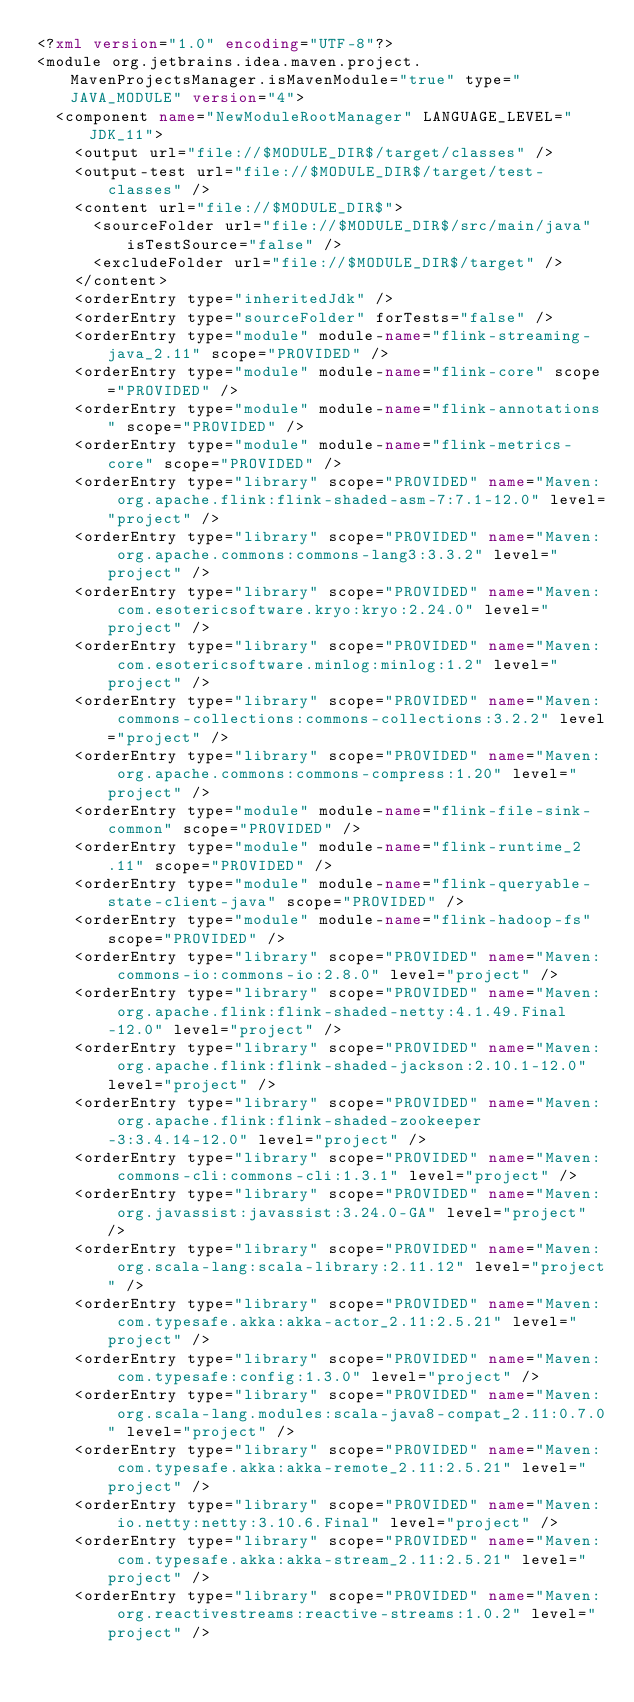<code> <loc_0><loc_0><loc_500><loc_500><_XML_><?xml version="1.0" encoding="UTF-8"?>
<module org.jetbrains.idea.maven.project.MavenProjectsManager.isMavenModule="true" type="JAVA_MODULE" version="4">
  <component name="NewModuleRootManager" LANGUAGE_LEVEL="JDK_11">
    <output url="file://$MODULE_DIR$/target/classes" />
    <output-test url="file://$MODULE_DIR$/target/test-classes" />
    <content url="file://$MODULE_DIR$">
      <sourceFolder url="file://$MODULE_DIR$/src/main/java" isTestSource="false" />
      <excludeFolder url="file://$MODULE_DIR$/target" />
    </content>
    <orderEntry type="inheritedJdk" />
    <orderEntry type="sourceFolder" forTests="false" />
    <orderEntry type="module" module-name="flink-streaming-java_2.11" scope="PROVIDED" />
    <orderEntry type="module" module-name="flink-core" scope="PROVIDED" />
    <orderEntry type="module" module-name="flink-annotations" scope="PROVIDED" />
    <orderEntry type="module" module-name="flink-metrics-core" scope="PROVIDED" />
    <orderEntry type="library" scope="PROVIDED" name="Maven: org.apache.flink:flink-shaded-asm-7:7.1-12.0" level="project" />
    <orderEntry type="library" scope="PROVIDED" name="Maven: org.apache.commons:commons-lang3:3.3.2" level="project" />
    <orderEntry type="library" scope="PROVIDED" name="Maven: com.esotericsoftware.kryo:kryo:2.24.0" level="project" />
    <orderEntry type="library" scope="PROVIDED" name="Maven: com.esotericsoftware.minlog:minlog:1.2" level="project" />
    <orderEntry type="library" scope="PROVIDED" name="Maven: commons-collections:commons-collections:3.2.2" level="project" />
    <orderEntry type="library" scope="PROVIDED" name="Maven: org.apache.commons:commons-compress:1.20" level="project" />
    <orderEntry type="module" module-name="flink-file-sink-common" scope="PROVIDED" />
    <orderEntry type="module" module-name="flink-runtime_2.11" scope="PROVIDED" />
    <orderEntry type="module" module-name="flink-queryable-state-client-java" scope="PROVIDED" />
    <orderEntry type="module" module-name="flink-hadoop-fs" scope="PROVIDED" />
    <orderEntry type="library" scope="PROVIDED" name="Maven: commons-io:commons-io:2.8.0" level="project" />
    <orderEntry type="library" scope="PROVIDED" name="Maven: org.apache.flink:flink-shaded-netty:4.1.49.Final-12.0" level="project" />
    <orderEntry type="library" scope="PROVIDED" name="Maven: org.apache.flink:flink-shaded-jackson:2.10.1-12.0" level="project" />
    <orderEntry type="library" scope="PROVIDED" name="Maven: org.apache.flink:flink-shaded-zookeeper-3:3.4.14-12.0" level="project" />
    <orderEntry type="library" scope="PROVIDED" name="Maven: commons-cli:commons-cli:1.3.1" level="project" />
    <orderEntry type="library" scope="PROVIDED" name="Maven: org.javassist:javassist:3.24.0-GA" level="project" />
    <orderEntry type="library" scope="PROVIDED" name="Maven: org.scala-lang:scala-library:2.11.12" level="project" />
    <orderEntry type="library" scope="PROVIDED" name="Maven: com.typesafe.akka:akka-actor_2.11:2.5.21" level="project" />
    <orderEntry type="library" scope="PROVIDED" name="Maven: com.typesafe:config:1.3.0" level="project" />
    <orderEntry type="library" scope="PROVIDED" name="Maven: org.scala-lang.modules:scala-java8-compat_2.11:0.7.0" level="project" />
    <orderEntry type="library" scope="PROVIDED" name="Maven: com.typesafe.akka:akka-remote_2.11:2.5.21" level="project" />
    <orderEntry type="library" scope="PROVIDED" name="Maven: io.netty:netty:3.10.6.Final" level="project" />
    <orderEntry type="library" scope="PROVIDED" name="Maven: com.typesafe.akka:akka-stream_2.11:2.5.21" level="project" />
    <orderEntry type="library" scope="PROVIDED" name="Maven: org.reactivestreams:reactive-streams:1.0.2" level="project" /></code> 